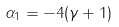Convert formula to latex. <formula><loc_0><loc_0><loc_500><loc_500>\alpha _ { 1 } = - 4 ( \gamma + 1 )</formula> 